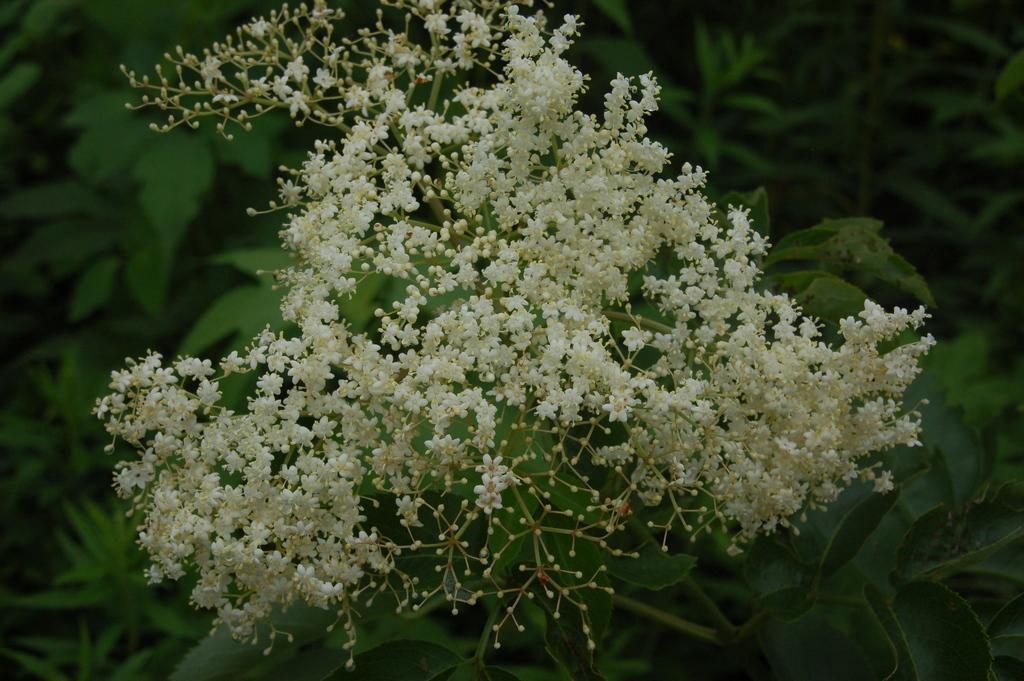What type of plants can be seen in the image? There are flowers in the image. What color are the flowers? The flowers are white in color. What else can be seen in the background of the image? There are leaves in the background of the image. What color are the leaves? The leaves are green in color. What rule is being enforced in the country depicted in the image? The image does not depict a country or any rules being enforced. What riddle can be solved using the information in the image? There is no riddle present in the image, as it only features flowers and leaves. 